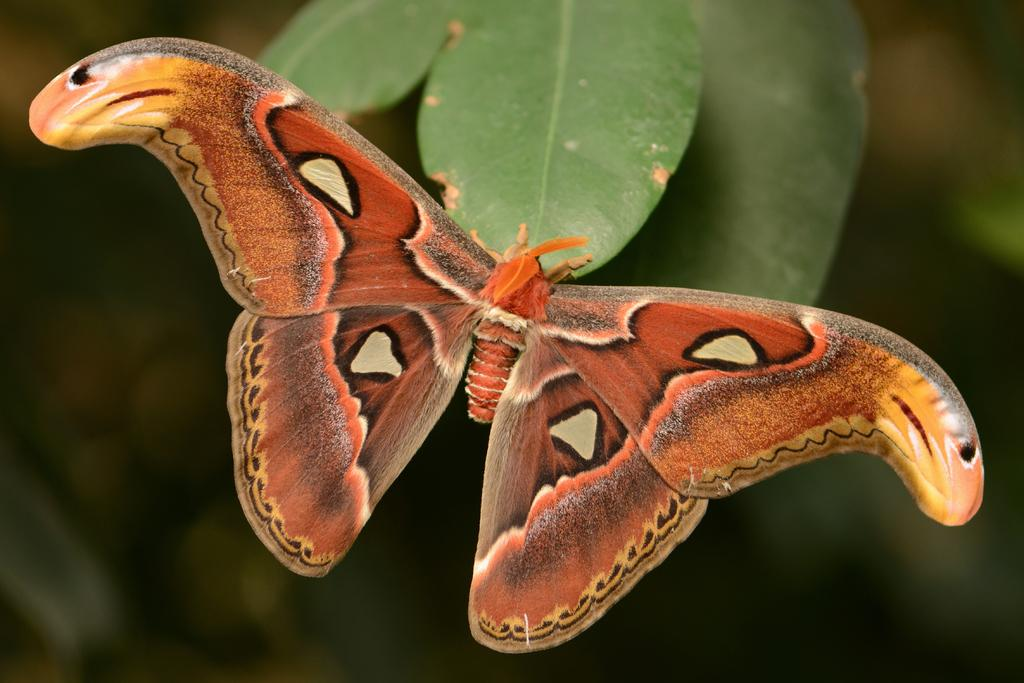What is the main subject of the picture? The main subject of the picture is a butterfly. Can you describe the color of the butterfly? The butterfly is orange in color. What else can be seen in the picture besides the butterfly? There are leaves in the picture. How would you describe the background of the image? The background of the image is blurred. What type of polish is the doll using in the image? There is no doll or polish present in the image; it features a butterfly and leaves. What fact can be learned about the butterfly's habitat from the image? The image does not provide enough information to determine the butterfly's habitat. 